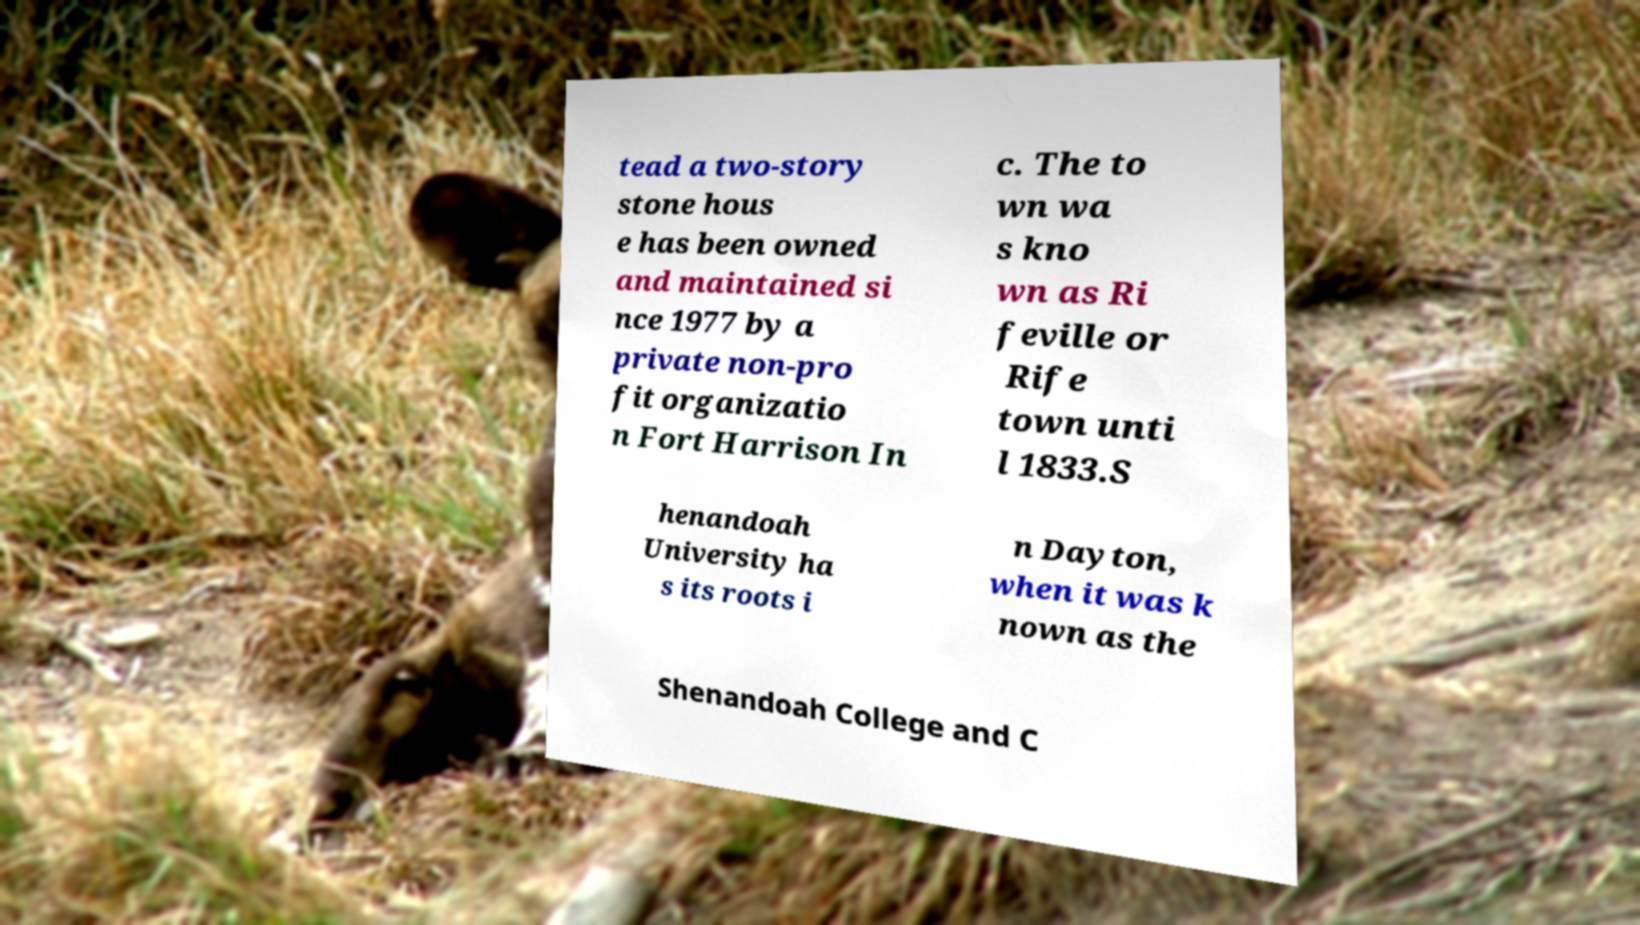Please read and relay the text visible in this image. What does it say? tead a two-story stone hous e has been owned and maintained si nce 1977 by a private non-pro fit organizatio n Fort Harrison In c. The to wn wa s kno wn as Ri feville or Rife town unti l 1833.S henandoah University ha s its roots i n Dayton, when it was k nown as the Shenandoah College and C 